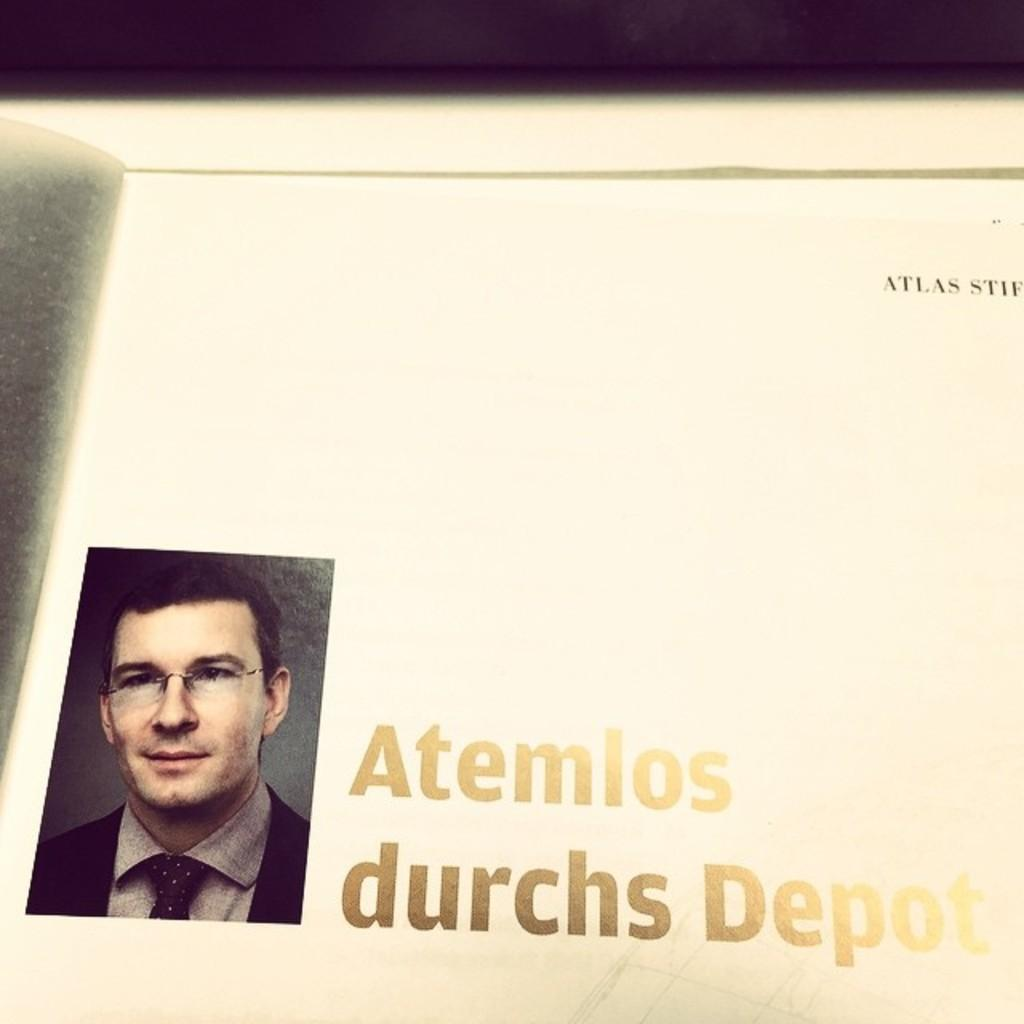What type of object is shown in the image? There is a page of a book in the image. What can be seen on the page of the book? There is a photograph of a person in the image. What else is present on the page of the book? There is text present in the image. How many wires are connected to the tin in the image? There is no tin or wire present in the image. 